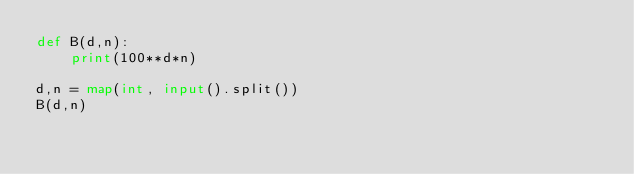Convert code to text. <code><loc_0><loc_0><loc_500><loc_500><_Python_>def B(d,n):
    print(100**d*n)

d,n = map(int, input().split())
B(d,n)
</code> 